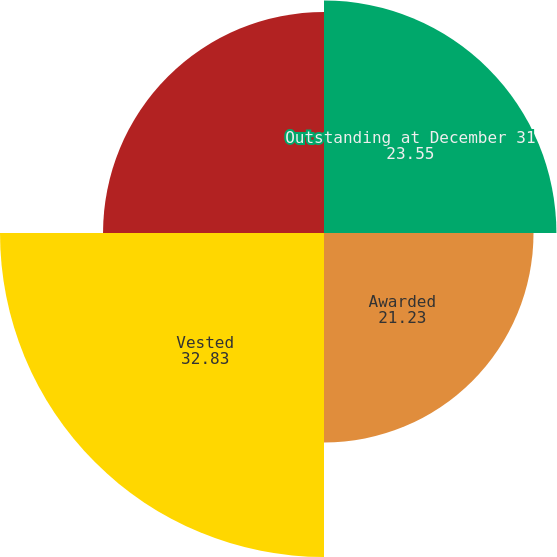Convert chart. <chart><loc_0><loc_0><loc_500><loc_500><pie_chart><fcel>Outstanding at December 31<fcel>Awarded<fcel>Vested<fcel>Forfeited<nl><fcel>23.55%<fcel>21.23%<fcel>32.83%<fcel>22.39%<nl></chart> 